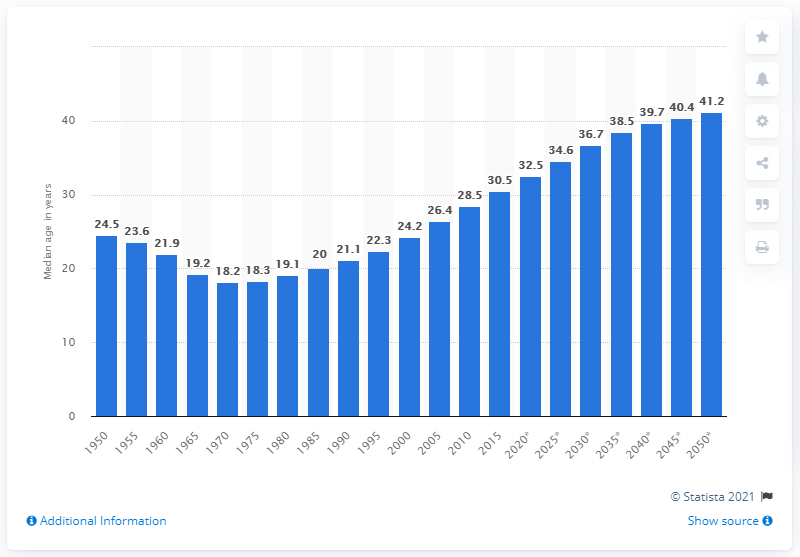Draw attention to some important aspects in this diagram. In 1970, the median age in Vietnam reached its lowest point. 